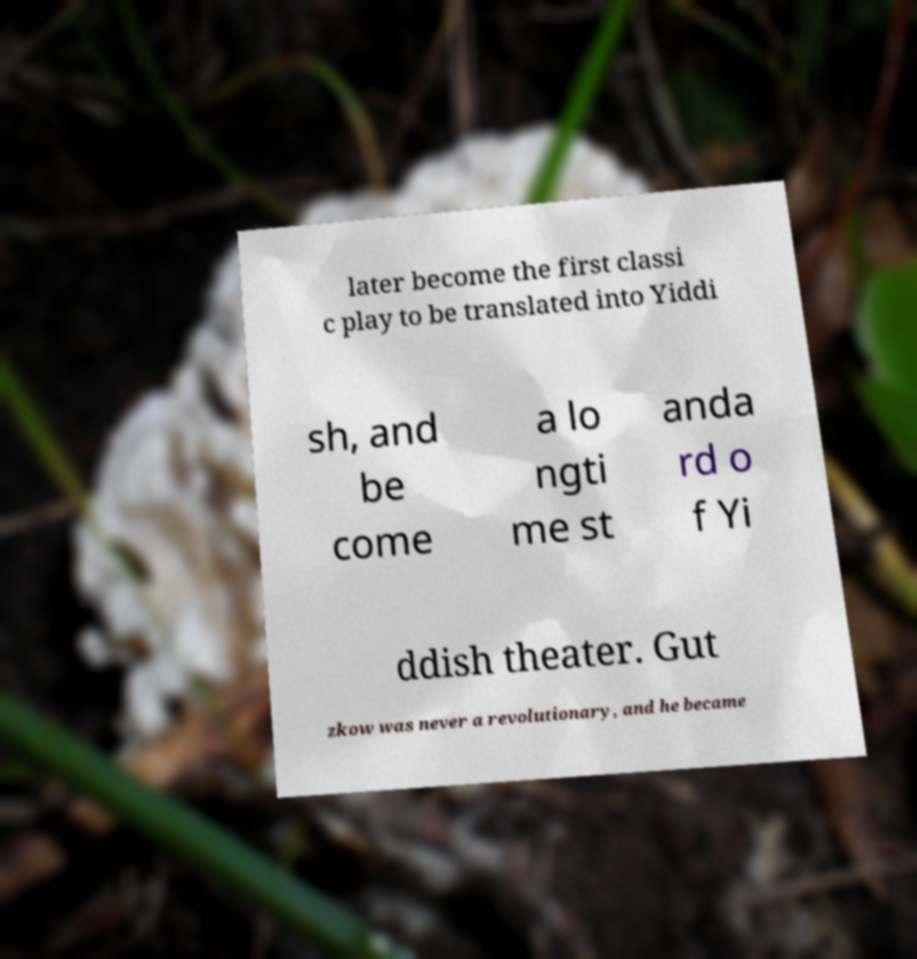There's text embedded in this image that I need extracted. Can you transcribe it verbatim? later become the first classi c play to be translated into Yiddi sh, and be come a lo ngti me st anda rd o f Yi ddish theater. Gut zkow was never a revolutionary, and he became 